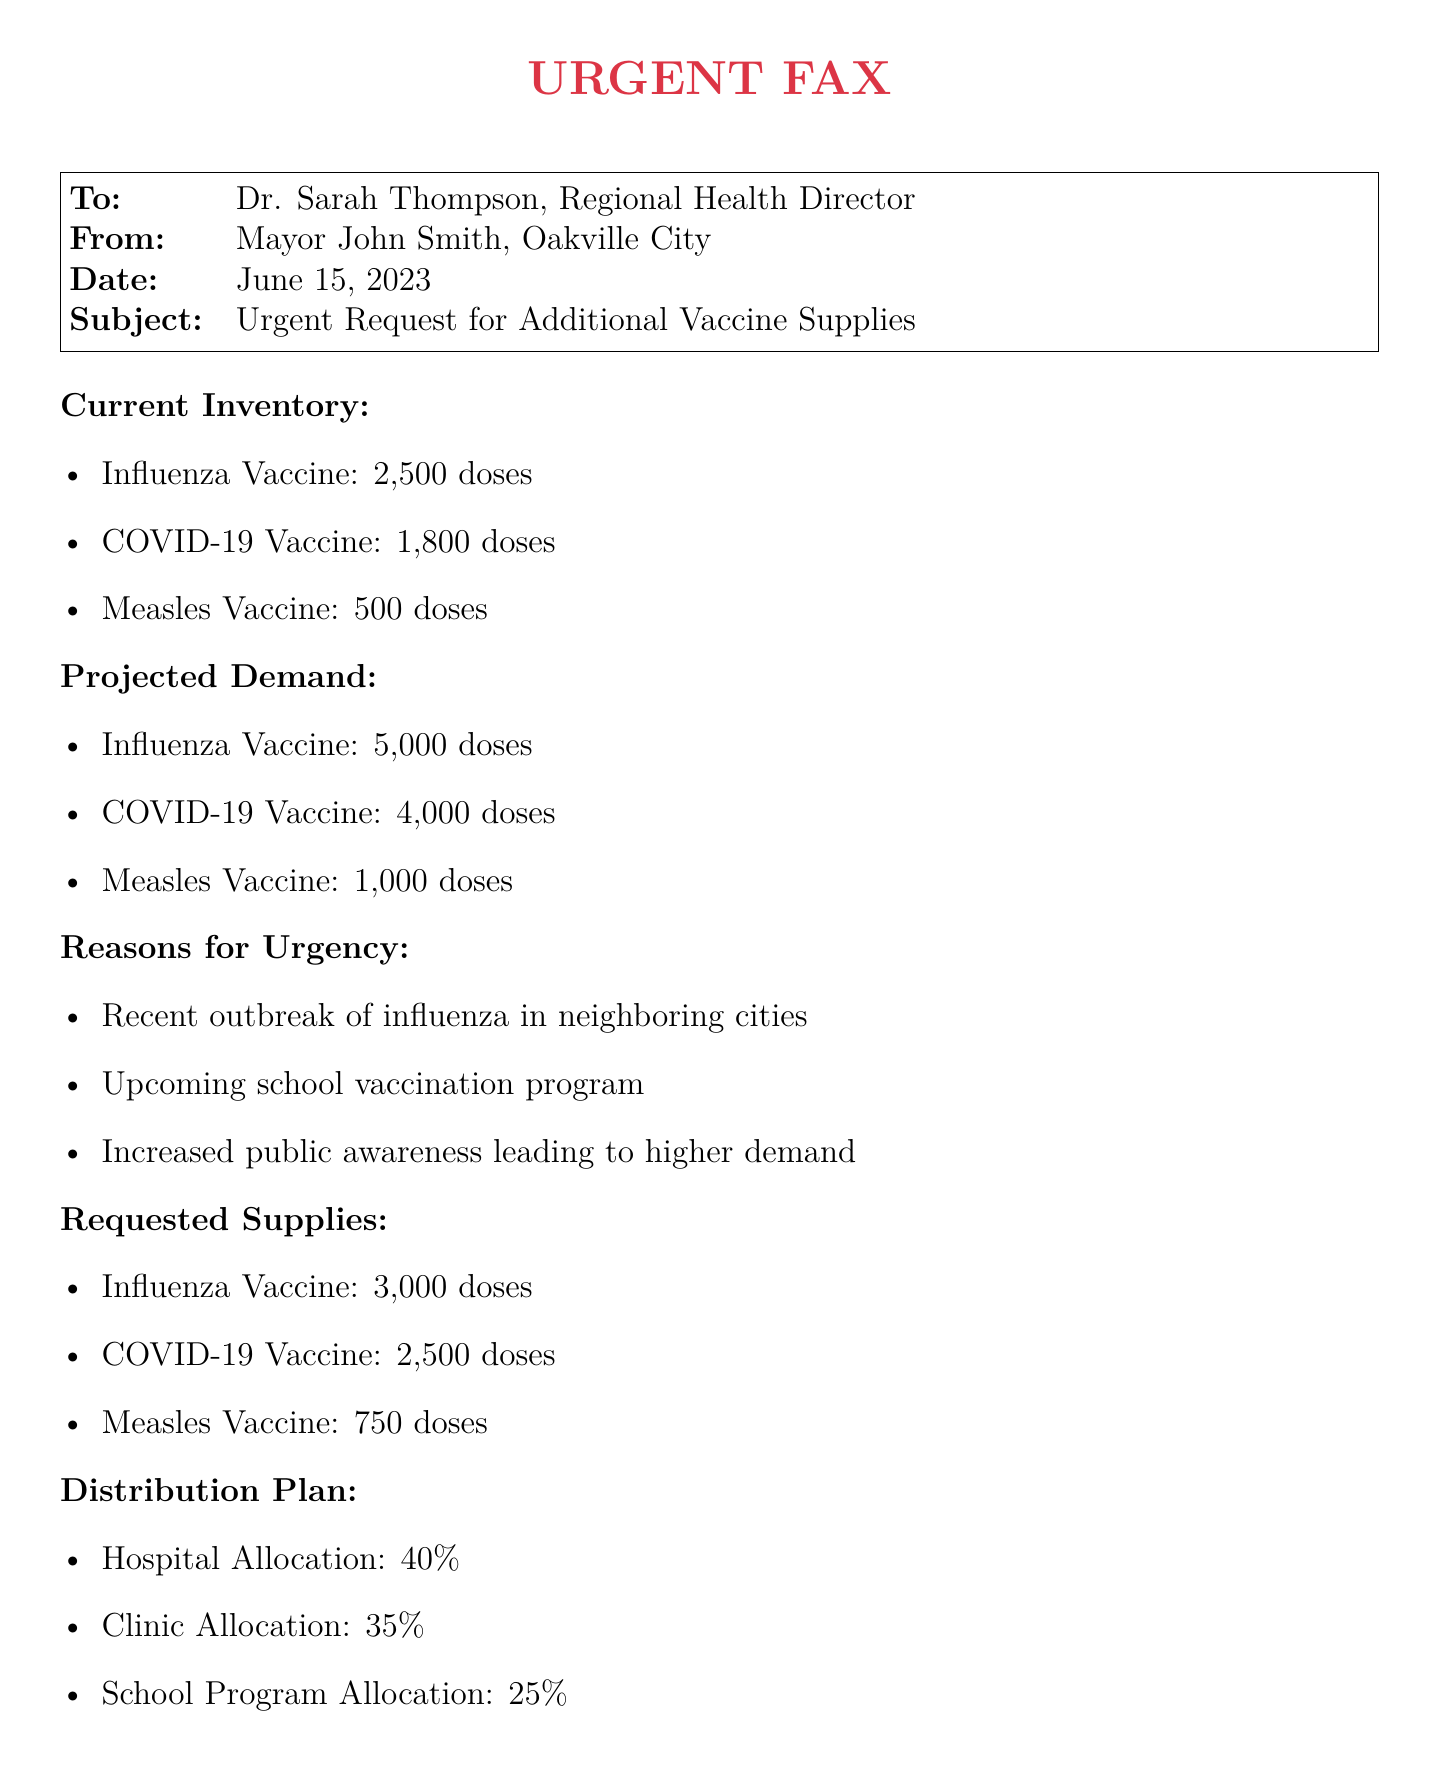What is the current inventory of COVID-19 Vaccine? The document states that the current inventory of the COVID-19 Vaccine is 1,800 doses.
Answer: 1,800 doses What is the total projected demand for Influenza Vaccine? The projected demand for the Influenza Vaccine is directly provided in the document, which is 5,000 doses.
Answer: 5,000 doses Who is the sender of this fax? The sender of the fax is identified as Mayor John Smith in the document.
Answer: Mayor John Smith What percentage of the requested vaccines is allocated to hospitals? The distribution plan specifies that 40% of the requested vaccines will be allocated to hospitals.
Answer: 40% What is the date of the fax? The date of the fax is mentioned as June 15, 2023, in the document.
Answer: June 15, 2023 How many additional doses of COVID-19 Vaccine are being requested? The document states that an additional 2,500 doses of the COVID-19 Vaccine are being requested.
Answer: 2,500 doses What is the main reason for urgency in this request? The document lists several reasons for urgency, one of which is the recent outbreak of influenza in neighboring cities.
Answer: Recent outbreak of influenza What is the total number of doses requested across all vaccines? The total number of doses requested is calculated by summing up the requested doses for each vaccine: 3,000 + 2,500 + 750 = 6,250 doses.
Answer: 6,250 doses Who should be contacted for more information regarding this fax? The document provides the contact information of Dr. Emily Chen, who is the City Health Officer.
Answer: Dr. Emily Chen 